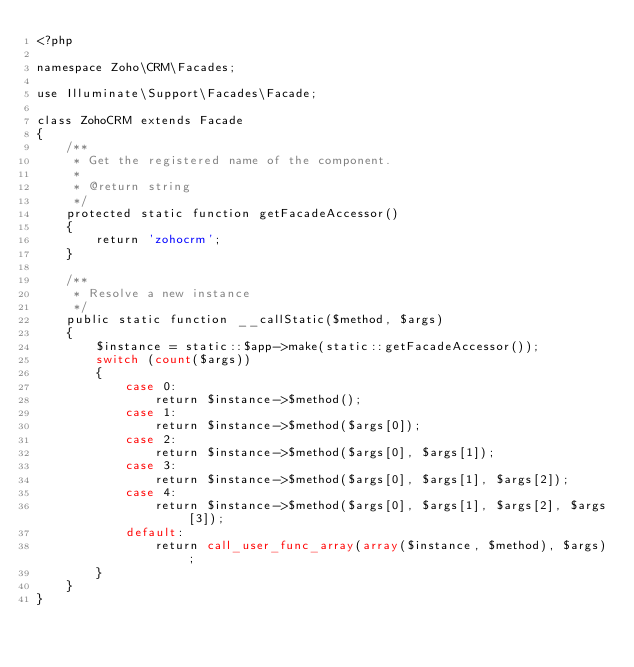<code> <loc_0><loc_0><loc_500><loc_500><_PHP_><?php

namespace Zoho\CRM\Facades;

use Illuminate\Support\Facades\Facade;

class ZohoCRM extends Facade
{
    /**
     * Get the registered name of the component.
     *
     * @return string
     */
    protected static function getFacadeAccessor()
    {
        return 'zohocrm';
    }

    /**
     * Resolve a new instance
     */
    public static function __callStatic($method, $args)
    {
        $instance = static::$app->make(static::getFacadeAccessor());
        switch (count($args))
        {
            case 0:
                return $instance->$method();
            case 1:
                return $instance->$method($args[0]);
            case 2:
                return $instance->$method($args[0], $args[1]);
            case 3:
                return $instance->$method($args[0], $args[1], $args[2]);
            case 4:
                return $instance->$method($args[0], $args[1], $args[2], $args[3]);
            default:
                return call_user_func_array(array($instance, $method), $args);
        }
    }
}
</code> 